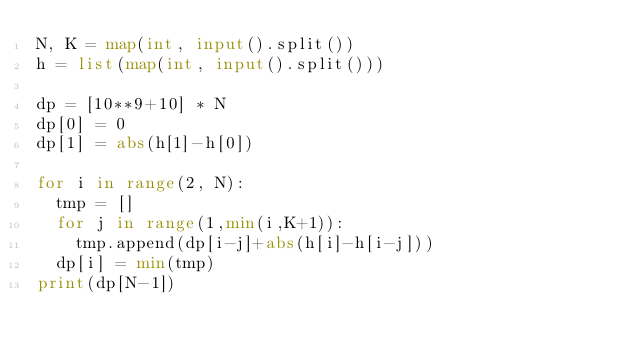Convert code to text. <code><loc_0><loc_0><loc_500><loc_500><_Python_>N, K = map(int, input().split())
h = list(map(int, input().split()))

dp = [10**9+10] * N
dp[0] = 0
dp[1] = abs(h[1]-h[0])

for i in range(2, N):
  tmp = []
  for j in range(1,min(i,K+1)):
    tmp.append(dp[i-j]+abs(h[i]-h[i-j]))
  dp[i] = min(tmp)
print(dp[N-1])</code> 